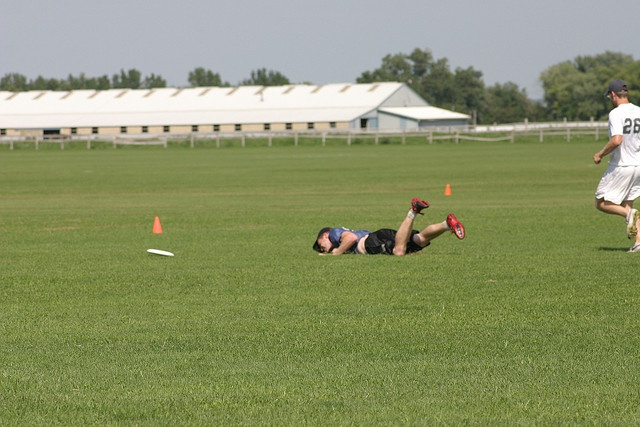Describe the objects in this image and their specific colors. I can see people in darkgray, white, gray, and olive tones, people in darkgray, black, tan, and olive tones, and frisbee in darkgray, white, darkgreen, olive, and beige tones in this image. 